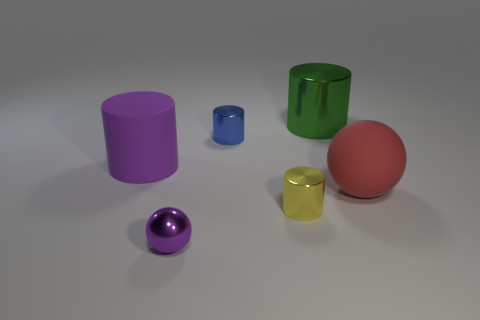How many things are yellow objects or metal cylinders that are on the left side of the tiny yellow metallic cylinder?
Your response must be concise. 2. Does the large cylinder in front of the large metallic cylinder have the same material as the cylinder that is behind the blue cylinder?
Offer a very short reply. No. There is a small object that is the same color as the rubber cylinder; what shape is it?
Offer a terse response. Sphere. How many red things are either tiny shiny objects or matte objects?
Provide a succinct answer. 1. The red rubber thing is what size?
Make the answer very short. Large. Is the number of green cylinders that are to the right of the green cylinder greater than the number of small yellow things?
Provide a succinct answer. No. There is a large red rubber object; what number of big red rubber objects are behind it?
Keep it short and to the point. 0. Are there any things of the same size as the shiny sphere?
Ensure brevity in your answer.  Yes. What color is the big metallic thing that is the same shape as the small blue thing?
Your answer should be very brief. Green. Does the metallic cylinder in front of the small blue shiny cylinder have the same size as the ball that is to the right of the yellow metal thing?
Your response must be concise. No. 